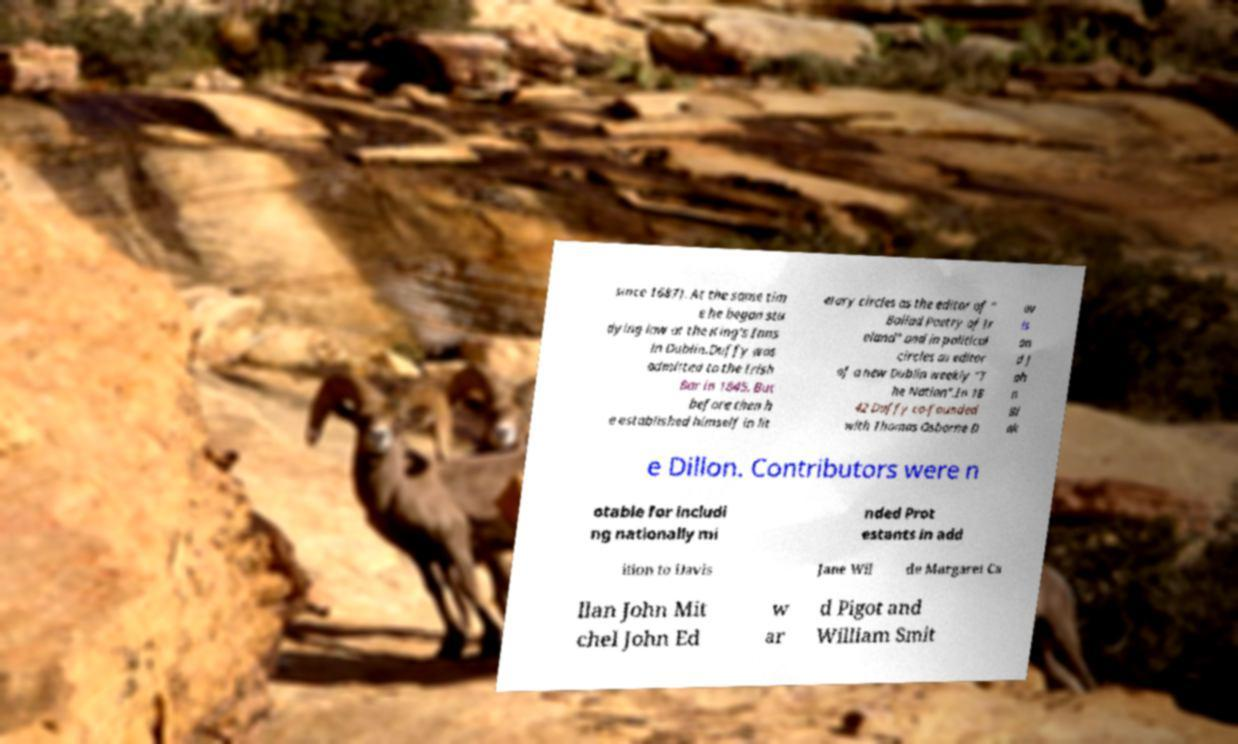There's text embedded in this image that I need extracted. Can you transcribe it verbatim? since 1687). At the same tim e he began stu dying law at the King's Inns in Dublin.Duffy was admitted to the Irish Bar in 1845. But before then h e established himself in lit erary circles as the editor of " Ballad Poetry of Ir eland" and in political circles as editor of a new Dublin weekly "T he Nation".In 18 42 Duffy co-founded with Thomas Osborne D av is an d J oh n Bl ak e Dillon. Contributors were n otable for includi ng nationally mi nded Prot estants in add ition to Davis Jane Wil de Margaret Ca llan John Mit chel John Ed w ar d Pigot and William Smit 